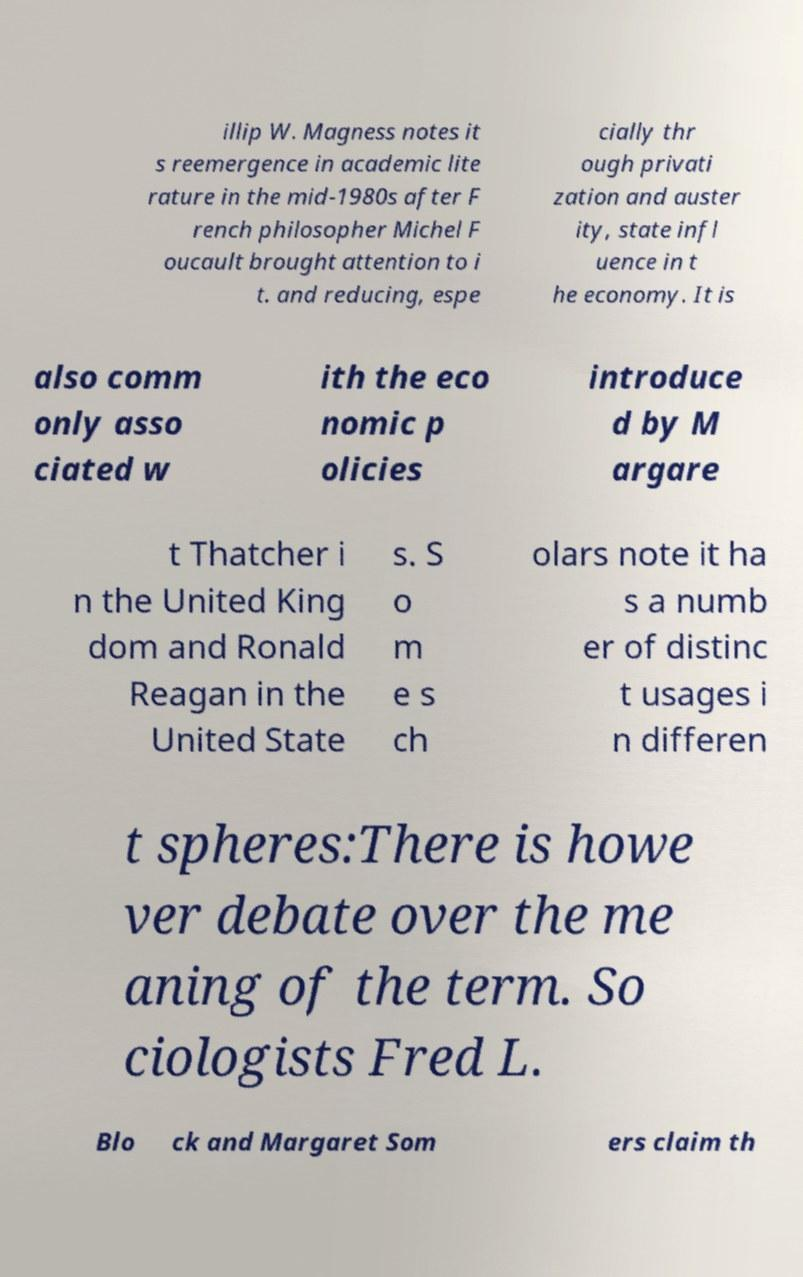What messages or text are displayed in this image? I need them in a readable, typed format. illip W. Magness notes it s reemergence in academic lite rature in the mid-1980s after F rench philosopher Michel F oucault brought attention to i t. and reducing, espe cially thr ough privati zation and auster ity, state infl uence in t he economy. It is also comm only asso ciated w ith the eco nomic p olicies introduce d by M argare t Thatcher i n the United King dom and Ronald Reagan in the United State s. S o m e s ch olars note it ha s a numb er of distinc t usages i n differen t spheres:There is howe ver debate over the me aning of the term. So ciologists Fred L. Blo ck and Margaret Som ers claim th 